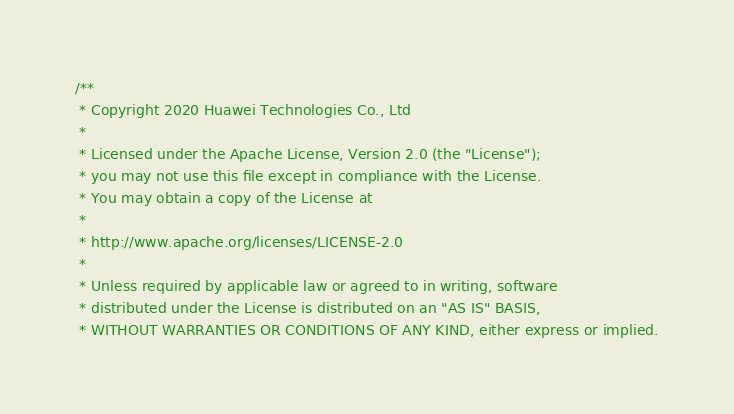Convert code to text. <code><loc_0><loc_0><loc_500><loc_500><_C_>/**
 * Copyright 2020 Huawei Technologies Co., Ltd
 *
 * Licensed under the Apache License, Version 2.0 (the "License");
 * you may not use this file except in compliance with the License.
 * You may obtain a copy of the License at
 *
 * http://www.apache.org/licenses/LICENSE-2.0
 *
 * Unless required by applicable law or agreed to in writing, software
 * distributed under the License is distributed on an "AS IS" BASIS,
 * WITHOUT WARRANTIES OR CONDITIONS OF ANY KIND, either express or implied.</code> 